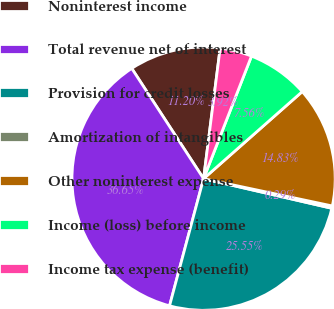Convert chart to OTSL. <chart><loc_0><loc_0><loc_500><loc_500><pie_chart><fcel>Noninterest income<fcel>Total revenue net of interest<fcel>Provision for credit losses<fcel>Amortization of intangibles<fcel>Other noninterest expense<fcel>Income (loss) before income<fcel>Income tax expense (benefit)<nl><fcel>11.2%<fcel>36.65%<fcel>25.55%<fcel>0.29%<fcel>14.83%<fcel>7.56%<fcel>3.92%<nl></chart> 